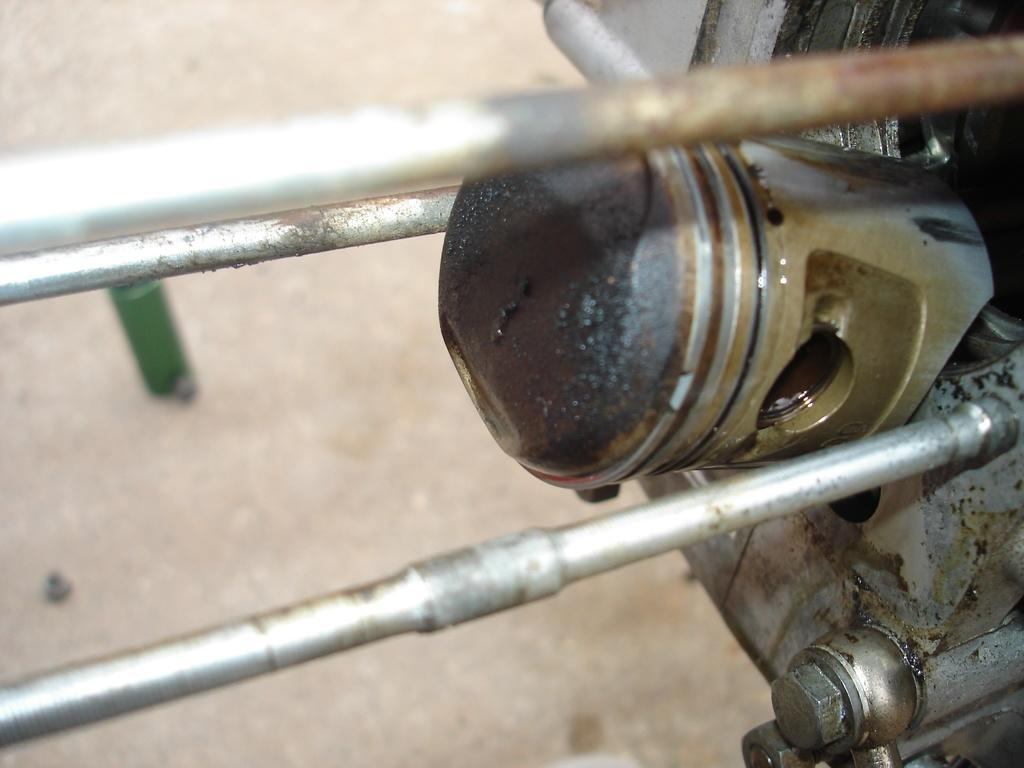What is the main subject of the image? The image appears to depict an engine. What specific parts can be seen in the engine? There are rods visible in the image. What is the background of the image? The ground is visible in the image. What type of shoes can be seen on the engine in the image? There are no shoes present in the image, as it depicts an engine and not a person wearing shoes. 